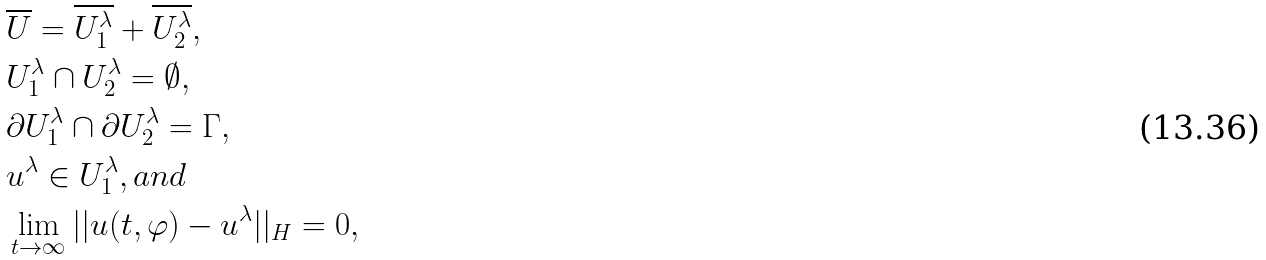Convert formula to latex. <formula><loc_0><loc_0><loc_500><loc_500>& \overline { U } = \overline { U ^ { \lambda } _ { 1 } } + \overline { U ^ { \lambda } _ { 2 } } , \\ & U ^ { \lambda } _ { 1 } \cap U ^ { \lambda } _ { 2 } = \emptyset , \\ & \partial U ^ { \lambda } _ { 1 } \cap \partial U ^ { \lambda } _ { 2 } = \Gamma , \\ & u ^ { \lambda } \in U ^ { \lambda } _ { 1 } , a n d \\ & \lim _ { t \rightarrow \infty } | | u ( t , \varphi ) - u ^ { \lambda } | | _ { H } = 0 , \\</formula> 